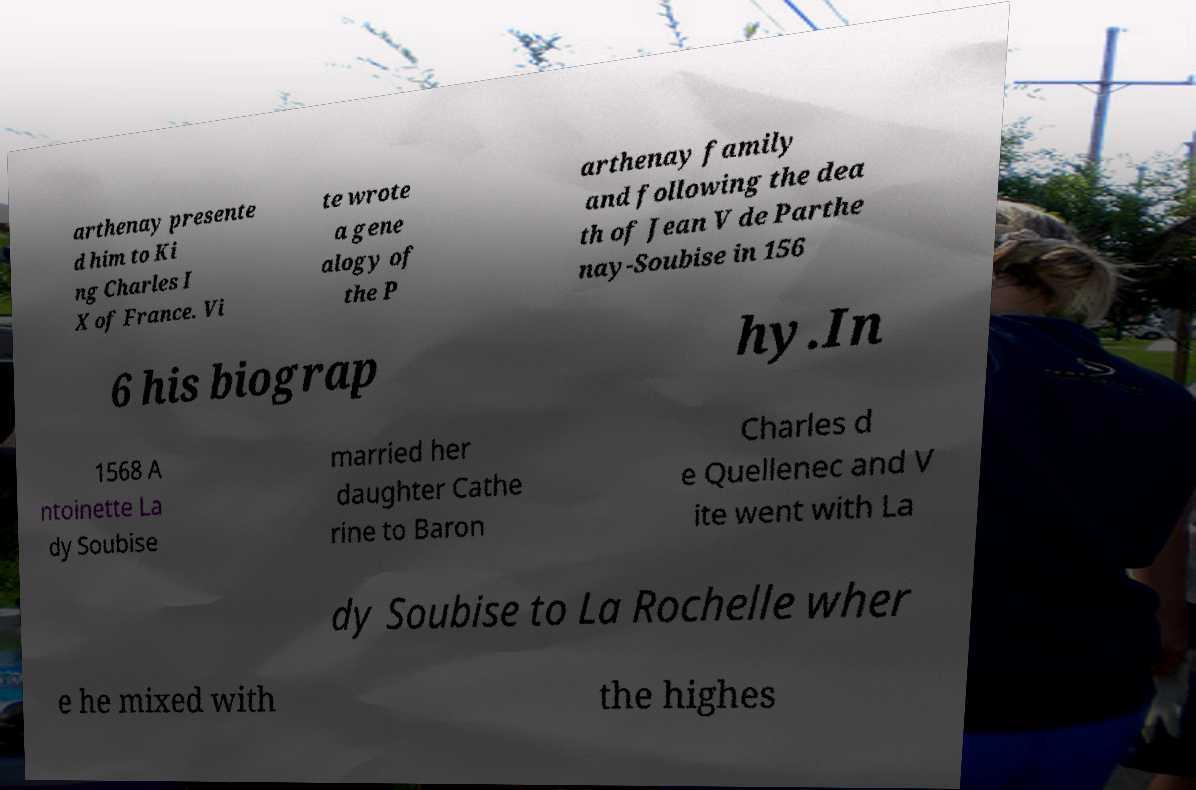Please identify and transcribe the text found in this image. arthenay presente d him to Ki ng Charles I X of France. Vi te wrote a gene alogy of the P arthenay family and following the dea th of Jean V de Parthe nay-Soubise in 156 6 his biograp hy.In 1568 A ntoinette La dy Soubise married her daughter Cathe rine to Baron Charles d e Quellenec and V ite went with La dy Soubise to La Rochelle wher e he mixed with the highes 